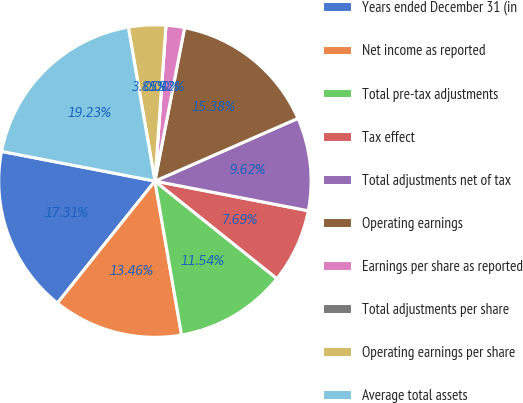<chart> <loc_0><loc_0><loc_500><loc_500><pie_chart><fcel>Years ended December 31 (in<fcel>Net income as reported<fcel>Total pre-tax adjustments<fcel>Tax effect<fcel>Total adjustments net of tax<fcel>Operating earnings<fcel>Earnings per share as reported<fcel>Total adjustments per share<fcel>Operating earnings per share<fcel>Average total assets<nl><fcel>17.31%<fcel>13.46%<fcel>11.54%<fcel>7.69%<fcel>9.62%<fcel>15.38%<fcel>1.92%<fcel>0.0%<fcel>3.85%<fcel>19.23%<nl></chart> 